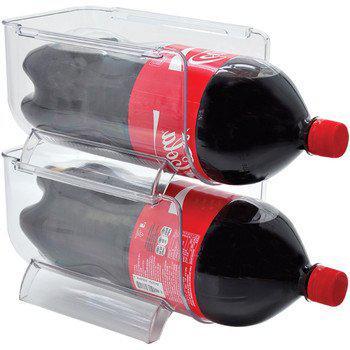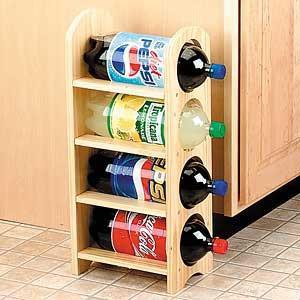The first image is the image on the left, the second image is the image on the right. Evaluate the accuracy of this statement regarding the images: "A person is pouring out the soda in one of the images.". Is it true? Answer yes or no. No. The first image is the image on the left, the second image is the image on the right. Assess this claim about the two images: "An image shows one hand gripping a handle attached to a horizontal bottle pouring cola into a glass under it on the left.". Correct or not? Answer yes or no. No. 